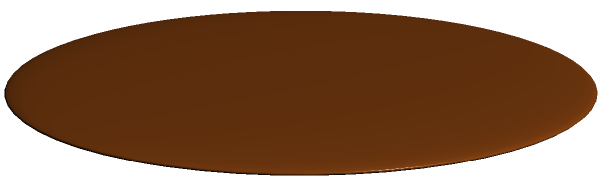During your adventures in the rainforest, you come across a fascinating conical termite mound. The mound has a circular base with a radius of 1.5 meters and stands 3 meters tall. Can you calculate the volume of this termite mound? (Use $\pi \approx 3.14$ for your calculations) Let's approach this step-by-step:

1) The volume of a cone is given by the formula:
   $$V = \frac{1}{3}\pi r^2 h$$
   where $r$ is the radius of the base and $h$ is the height.

2) We are given:
   $r = 1.5$ meters
   $h = 3$ meters

3) Let's substitute these values into our formula:
   $$V = \frac{1}{3} \pi (1.5)^2 (3)$$

4) First, let's calculate $r^2$:
   $$(1.5)^2 = 2.25$$

5) Now our equation looks like:
   $$V = \frac{1}{3} \pi (2.25) (3)$$

6) Multiply the numbers:
   $$V = \frac{1}{3} \pi (6.75)$$

7) Simplify:
   $$V = 2.25 \pi$$

8) Using $\pi \approx 3.14$:
   $$V \approx 2.25 (3.14) = 7.065$$

Therefore, the volume of the termite mound is approximately 7.065 cubic meters.
Answer: $7.065 \text{ m}^3$ 